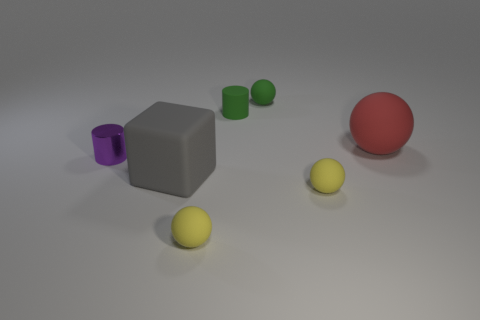Are there any green rubber things that are behind the sphere that is behind the large red object?
Ensure brevity in your answer.  No. There is a red thing that is on the right side of the matte cylinder; is its size the same as the gray rubber cube?
Keep it short and to the point. Yes. How big is the green cylinder?
Keep it short and to the point. Small. Is there a sphere that has the same color as the rubber cylinder?
Offer a terse response. Yes. How many small things are red objects or yellow objects?
Your response must be concise. 2. There is a rubber object that is both left of the tiny green rubber cylinder and in front of the gray block; how big is it?
Your answer should be very brief. Small. What number of tiny matte cylinders are to the right of the rubber cylinder?
Your answer should be compact. 0. What is the shape of the tiny object that is behind the large gray cube and in front of the large rubber sphere?
Offer a terse response. Cylinder. What is the material of the tiny ball that is the same color as the small matte cylinder?
Give a very brief answer. Rubber. How many cubes are either small green objects or tiny objects?
Your answer should be compact. 0. 